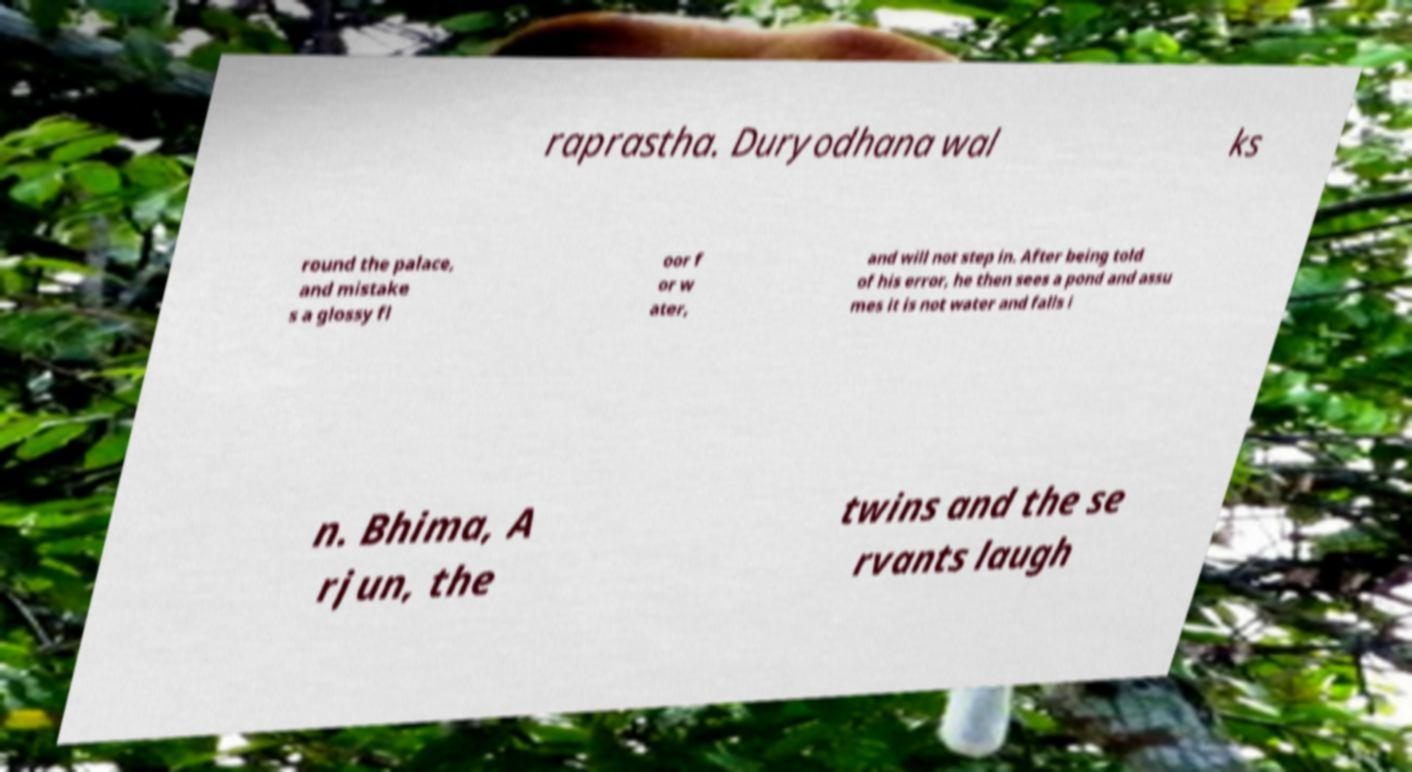Could you extract and type out the text from this image? raprastha. Duryodhana wal ks round the palace, and mistake s a glossy fl oor f or w ater, and will not step in. After being told of his error, he then sees a pond and assu mes it is not water and falls i n. Bhima, A rjun, the twins and the se rvants laugh 